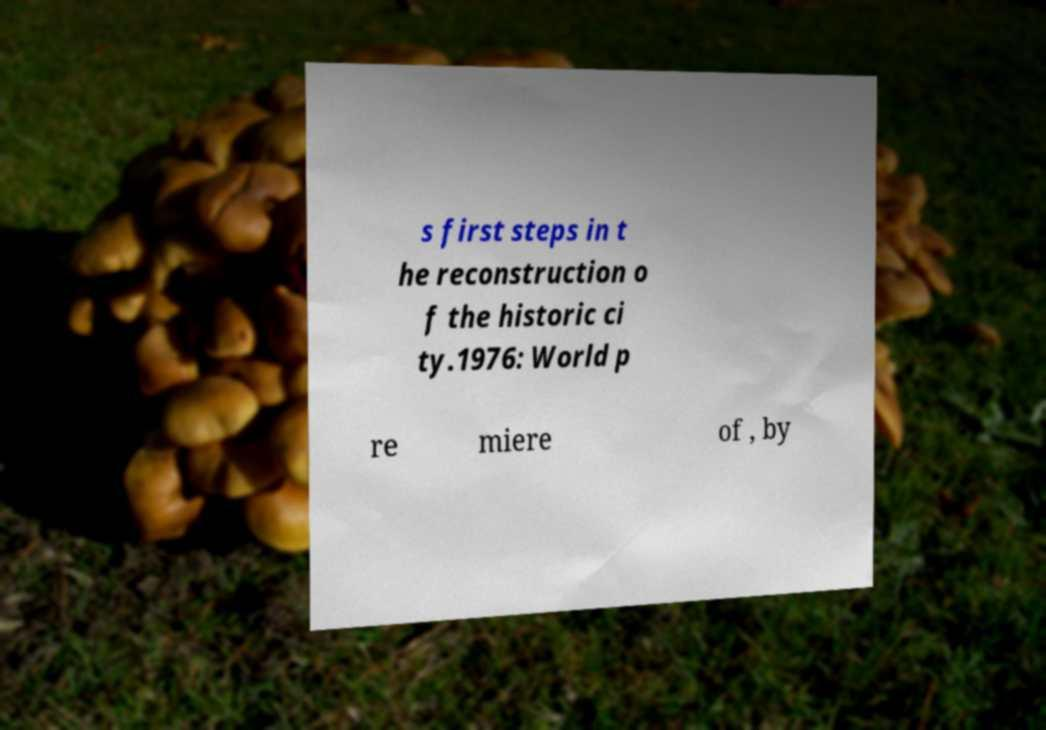I need the written content from this picture converted into text. Can you do that? s first steps in t he reconstruction o f the historic ci ty.1976: World p re miere of , by 